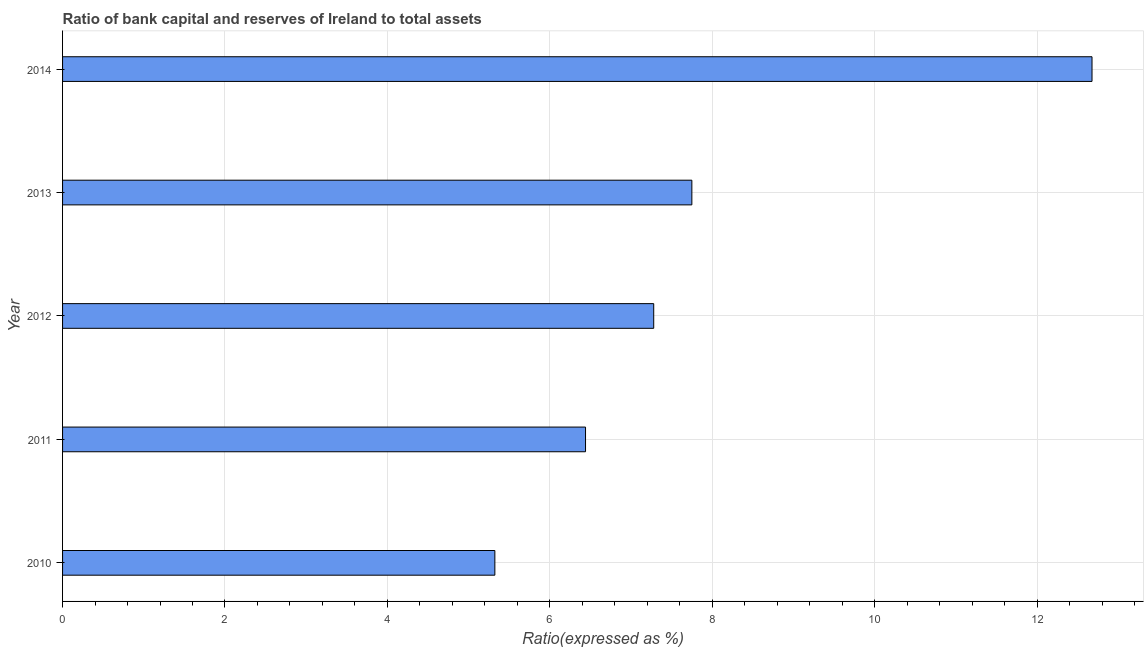Does the graph contain any zero values?
Offer a terse response. No. Does the graph contain grids?
Ensure brevity in your answer.  Yes. What is the title of the graph?
Ensure brevity in your answer.  Ratio of bank capital and reserves of Ireland to total assets. What is the label or title of the X-axis?
Your answer should be very brief. Ratio(expressed as %). What is the bank capital to assets ratio in 2014?
Offer a very short reply. 12.68. Across all years, what is the maximum bank capital to assets ratio?
Your answer should be compact. 12.68. Across all years, what is the minimum bank capital to assets ratio?
Make the answer very short. 5.32. What is the sum of the bank capital to assets ratio?
Your answer should be compact. 39.47. What is the difference between the bank capital to assets ratio in 2011 and 2014?
Give a very brief answer. -6.24. What is the average bank capital to assets ratio per year?
Offer a very short reply. 7.89. What is the median bank capital to assets ratio?
Give a very brief answer. 7.28. What is the ratio of the bank capital to assets ratio in 2011 to that in 2012?
Ensure brevity in your answer.  0.89. Is the difference between the bank capital to assets ratio in 2012 and 2013 greater than the difference between any two years?
Provide a short and direct response. No. What is the difference between the highest and the second highest bank capital to assets ratio?
Provide a succinct answer. 4.93. Is the sum of the bank capital to assets ratio in 2012 and 2013 greater than the maximum bank capital to assets ratio across all years?
Provide a succinct answer. Yes. What is the difference between the highest and the lowest bank capital to assets ratio?
Keep it short and to the point. 7.35. Are all the bars in the graph horizontal?
Keep it short and to the point. Yes. Are the values on the major ticks of X-axis written in scientific E-notation?
Your answer should be compact. No. What is the Ratio(expressed as %) in 2010?
Keep it short and to the point. 5.32. What is the Ratio(expressed as %) of 2011?
Offer a terse response. 6.44. What is the Ratio(expressed as %) of 2012?
Provide a short and direct response. 7.28. What is the Ratio(expressed as %) in 2013?
Your response must be concise. 7.75. What is the Ratio(expressed as %) in 2014?
Make the answer very short. 12.68. What is the difference between the Ratio(expressed as %) in 2010 and 2011?
Your answer should be compact. -1.12. What is the difference between the Ratio(expressed as %) in 2010 and 2012?
Give a very brief answer. -1.96. What is the difference between the Ratio(expressed as %) in 2010 and 2013?
Your answer should be compact. -2.43. What is the difference between the Ratio(expressed as %) in 2010 and 2014?
Provide a succinct answer. -7.35. What is the difference between the Ratio(expressed as %) in 2011 and 2012?
Provide a short and direct response. -0.84. What is the difference between the Ratio(expressed as %) in 2011 and 2013?
Offer a very short reply. -1.31. What is the difference between the Ratio(expressed as %) in 2011 and 2014?
Ensure brevity in your answer.  -6.24. What is the difference between the Ratio(expressed as %) in 2012 and 2013?
Make the answer very short. -0.47. What is the difference between the Ratio(expressed as %) in 2012 and 2014?
Make the answer very short. -5.4. What is the difference between the Ratio(expressed as %) in 2013 and 2014?
Your response must be concise. -4.93. What is the ratio of the Ratio(expressed as %) in 2010 to that in 2011?
Give a very brief answer. 0.83. What is the ratio of the Ratio(expressed as %) in 2010 to that in 2012?
Keep it short and to the point. 0.73. What is the ratio of the Ratio(expressed as %) in 2010 to that in 2013?
Offer a terse response. 0.69. What is the ratio of the Ratio(expressed as %) in 2010 to that in 2014?
Offer a terse response. 0.42. What is the ratio of the Ratio(expressed as %) in 2011 to that in 2012?
Your response must be concise. 0.89. What is the ratio of the Ratio(expressed as %) in 2011 to that in 2013?
Ensure brevity in your answer.  0.83. What is the ratio of the Ratio(expressed as %) in 2011 to that in 2014?
Offer a terse response. 0.51. What is the ratio of the Ratio(expressed as %) in 2012 to that in 2013?
Provide a short and direct response. 0.94. What is the ratio of the Ratio(expressed as %) in 2012 to that in 2014?
Keep it short and to the point. 0.57. What is the ratio of the Ratio(expressed as %) in 2013 to that in 2014?
Your answer should be compact. 0.61. 